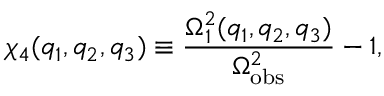Convert formula to latex. <formula><loc_0><loc_0><loc_500><loc_500>\chi _ { 4 } ( q _ { 1 } , q _ { 2 } , q _ { 3 } ) \equiv \frac { \Omega _ { 1 } ^ { 2 } ( q _ { 1 } , q _ { 2 } , q _ { 3 } ) } { \Omega _ { o b s } ^ { 2 } } - 1 ,</formula> 